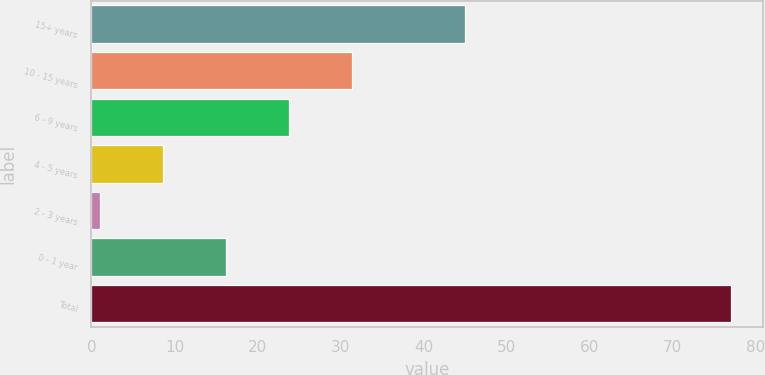<chart> <loc_0><loc_0><loc_500><loc_500><bar_chart><fcel>15+ years<fcel>10 - 15 years<fcel>6 - 9 years<fcel>4 - 5 years<fcel>2 - 3 years<fcel>0 - 1 year<fcel>Total<nl><fcel>45<fcel>31.4<fcel>23.8<fcel>8.6<fcel>1<fcel>16.2<fcel>77<nl></chart> 